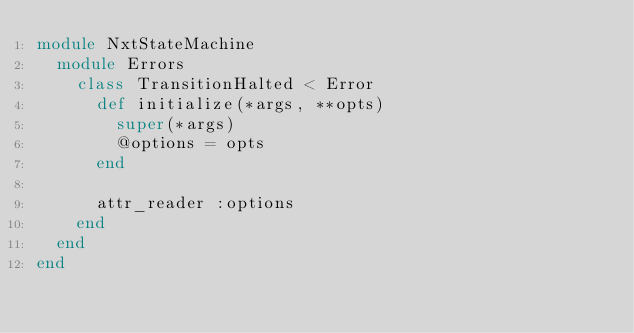Convert code to text. <code><loc_0><loc_0><loc_500><loc_500><_Ruby_>module NxtStateMachine
  module Errors
    class TransitionHalted < Error
      def initialize(*args, **opts)
        super(*args)
        @options = opts
      end

      attr_reader :options
    end
  end
end
</code> 